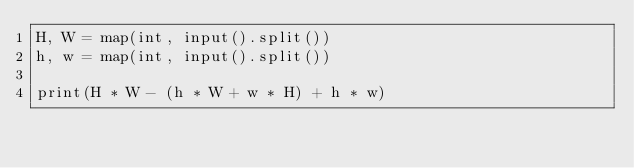Convert code to text. <code><loc_0><loc_0><loc_500><loc_500><_Python_>H, W = map(int, input().split())
h, w = map(int, input().split())

print(H * W - (h * W + w * H) + h * w)</code> 